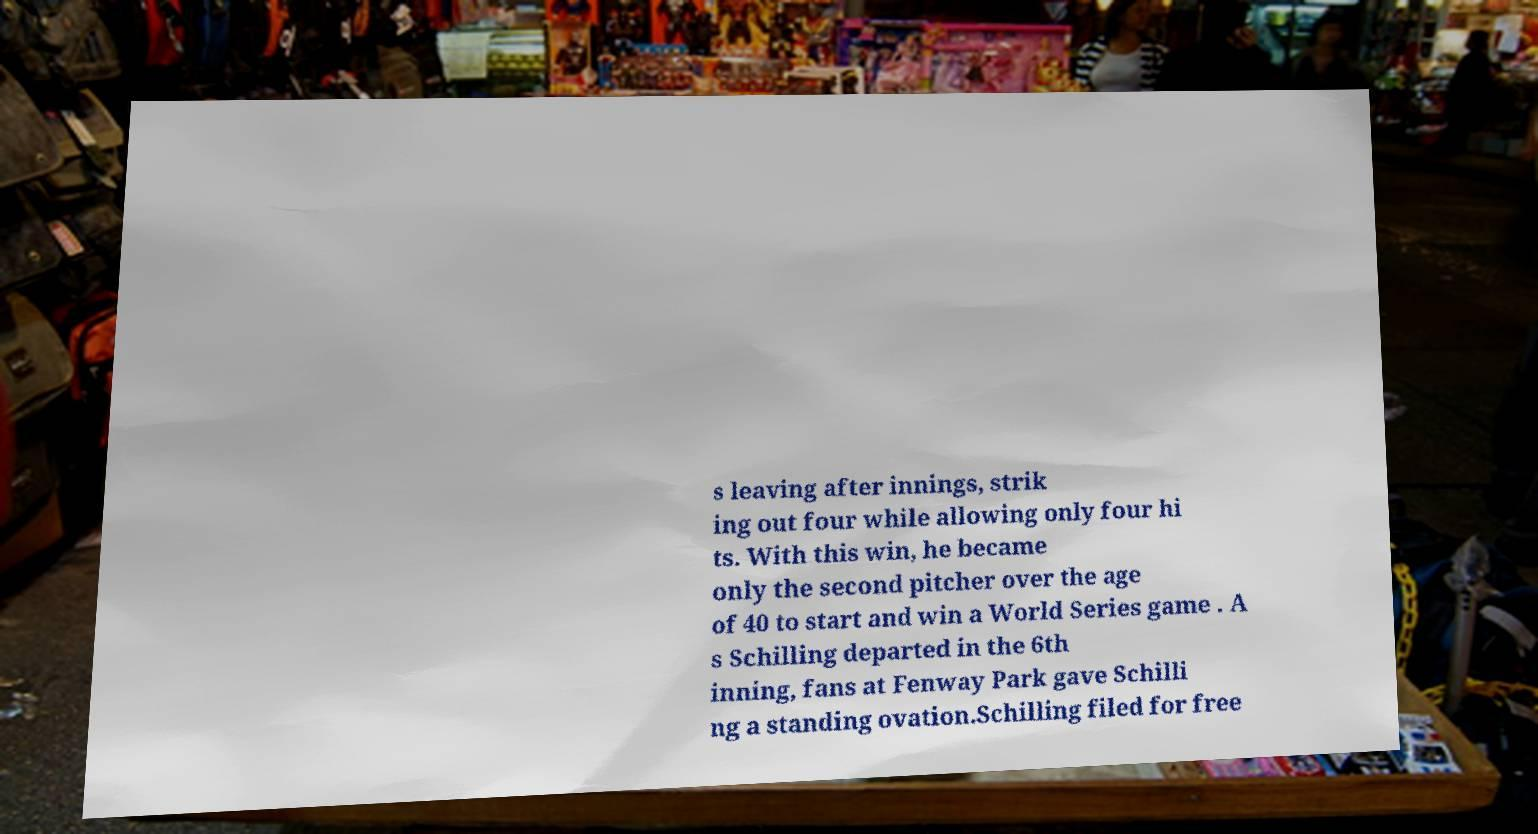What messages or text are displayed in this image? I need them in a readable, typed format. s leaving after innings, strik ing out four while allowing only four hi ts. With this win, he became only the second pitcher over the age of 40 to start and win a World Series game . A s Schilling departed in the 6th inning, fans at Fenway Park gave Schilli ng a standing ovation.Schilling filed for free 